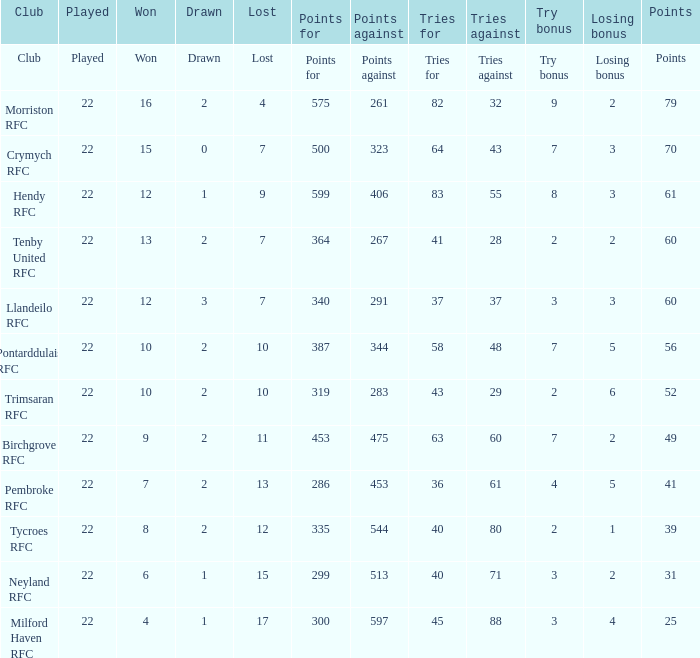What is the won with an attempt bonus of 8? 12.0. 